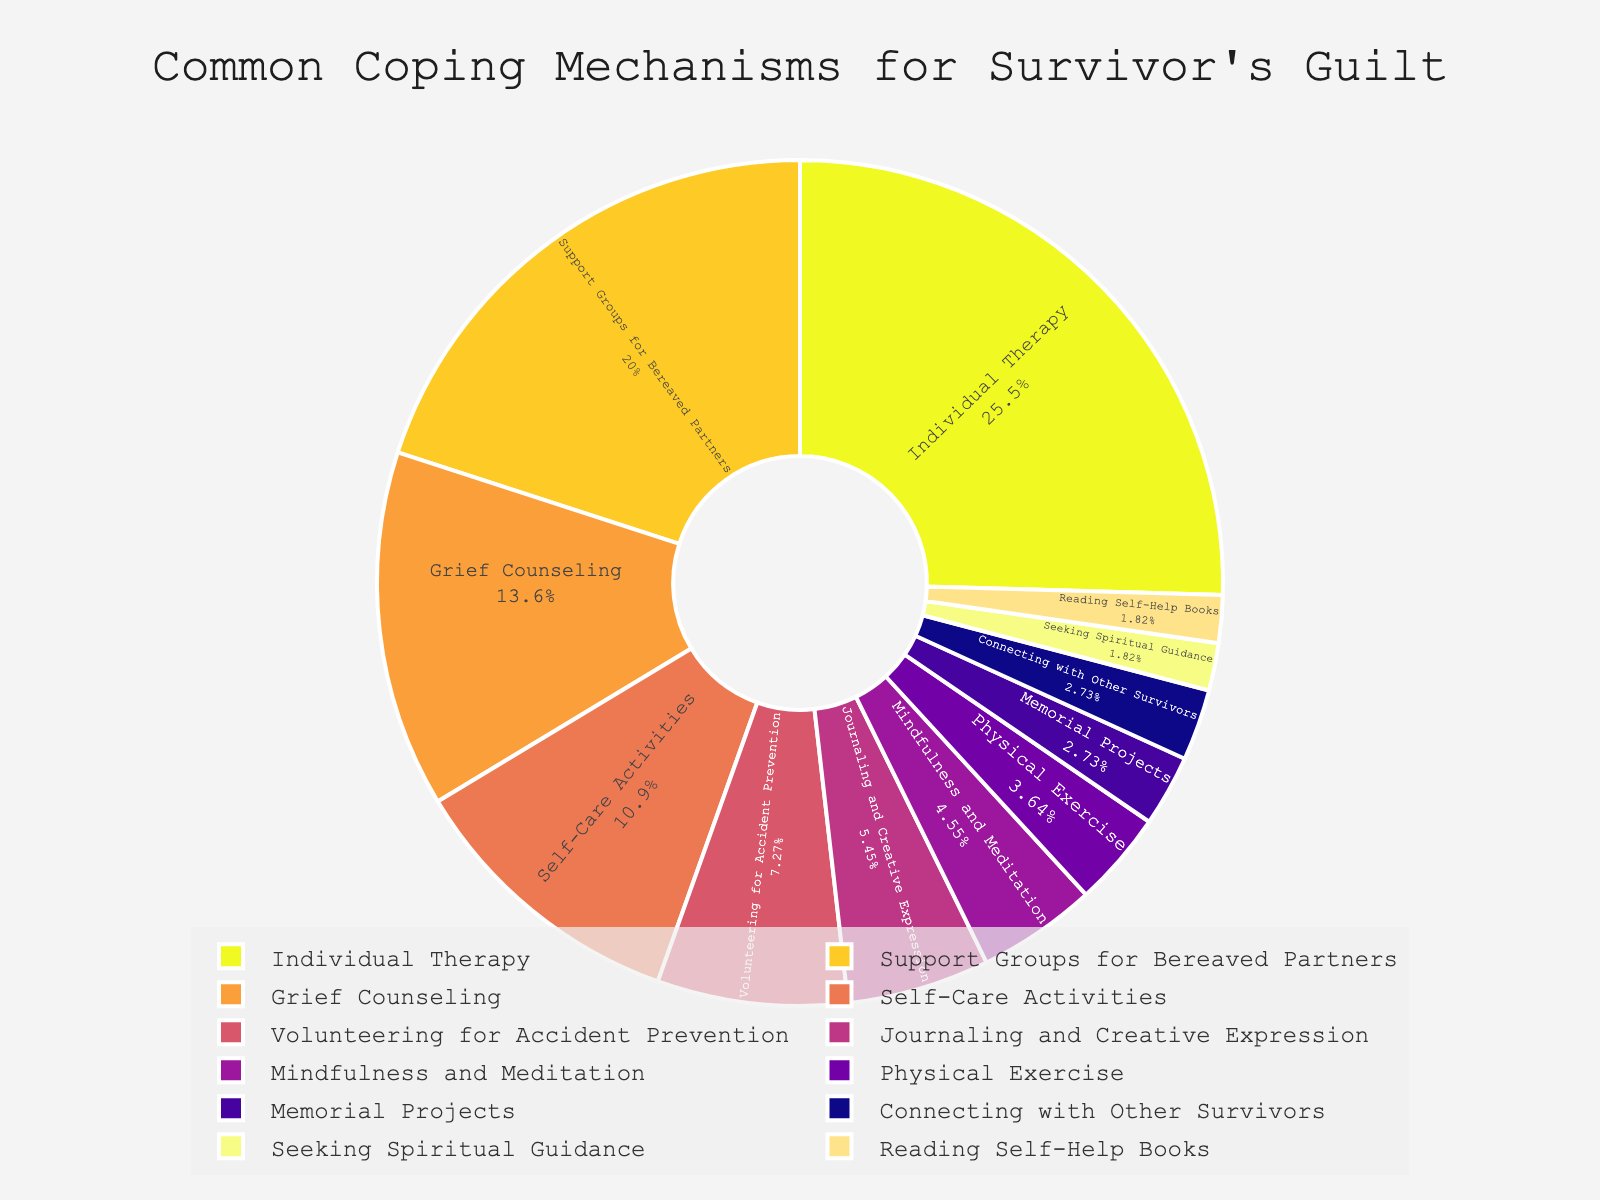What is the most common coping mechanism used by people dealing with survivor's guilt? The largest segment in the pie chart represents the most common coping mechanism. From the chart, the segment for "Individual Therapy" has the highest percentage.
Answer: Individual Therapy What is the combined percentage of people who use Support Groups for Bereaved Partners and Grief Counseling? To find the combined percentage of these two coping mechanisms, simply add their individual percentages: 22% for Support Groups for Bereaved Partners and 15% for Grief Counseling. So, 22% + 15% = 37%.
Answer: 37% Which coping mechanism is more commonly used than Self-Care Activities but less commonly used than Support Groups for Bereaved Partners? Look for segments that have a higher percentage than Self-Care Activities (12%) and a lower percentage than Support Groups for Bereaved Partners (22%). Grief Counseling at 15% fits this criteria.
Answer: Grief Counseling How does the percentage of people practicing Volunteering for Accident Prevention compare to those practicing Physical Exercise? The chart shows that Volunteering for Accident Prevention has a percentage of 8%, whereas Physical Exercise has a percentage of 4%. Therefore, Volunteering for Accident Prevention is twice as common as Physical Exercise.
Answer: Volunteering for Accident Prevention is twice as common as Physical Exercise What is the total percentage of people who use either Memorial Projects or Connecting with Other Survivors as their coping mechanism? Add the percentages of the two given coping mechanisms: Memorial Projects (3%) and Connecting with Other Survivors (3%), which equals 3% + 3% = 6%.
Answer: 6% What color is associated with the pie segment representing Mindfulness and Meditation? Visually inspect the color associated with the segment labeled "Mindfulness and Meditation". Given the color range from Plasma_r, it might be a distinctive color like yellow, orange, or a gradient.
Answer: A specific color from the chart (e.g., yellow or orange) How much more common is Individual Therapy compared to Seeking Spiritual Guidance? Individual Therapy represents 28%, while Seeking Spiritual Guidance represents 2%. To find how much more common, calculate the difference: 28% - 2% = 26%.
Answer: 26% more common Is there a coping mechanism used by an equal percentage of people as Journaling and Creative Expression? Look at the pie chart for a segment that has the same percentage as Journaling and Creative Expression, which is 6%. No other segment in the chart has this exact percentage.
Answer: No What is the percentage difference between people practicing Self-Care Activities and those reading Self-Help Books? Subtract the percentage of Self-Help Books (2%) from Self-Care Activities (12%): 12% - 2% = 10%.
Answer: 10% If you combined the percentages of people practicing Mindfulness and Meditation with those who read Self-Help Books, would it be greater than the percentage of those who practice Grief Counseling? Mindfulness and Meditation is 5%, and Reading Self-Help Books is 2%. Combined, they add up to 5% + 2% = 7%. Grief Counseling is 15%, so 7% is less than 15% and therefore not greater.
Answer: No 